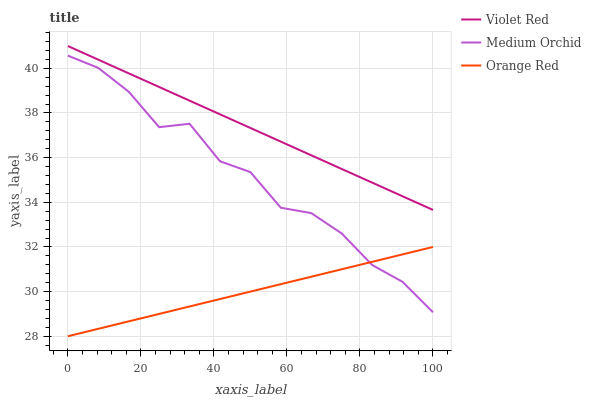Does Orange Red have the minimum area under the curve?
Answer yes or no. Yes. Does Violet Red have the maximum area under the curve?
Answer yes or no. Yes. Does Medium Orchid have the minimum area under the curve?
Answer yes or no. No. Does Medium Orchid have the maximum area under the curve?
Answer yes or no. No. Is Violet Red the smoothest?
Answer yes or no. Yes. Is Medium Orchid the roughest?
Answer yes or no. Yes. Is Orange Red the smoothest?
Answer yes or no. No. Is Orange Red the roughest?
Answer yes or no. No. Does Medium Orchid have the lowest value?
Answer yes or no. No. Does Violet Red have the highest value?
Answer yes or no. Yes. Does Medium Orchid have the highest value?
Answer yes or no. No. Is Orange Red less than Violet Red?
Answer yes or no. Yes. Is Violet Red greater than Orange Red?
Answer yes or no. Yes. Does Orange Red intersect Violet Red?
Answer yes or no. No. 